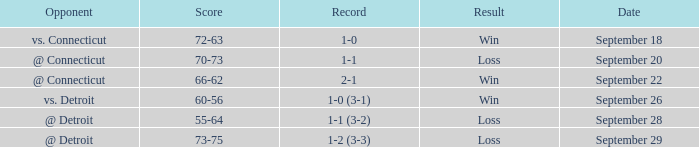WHAT IS THE SCORE WITH A RECORD OF 1-0? 72-63. 